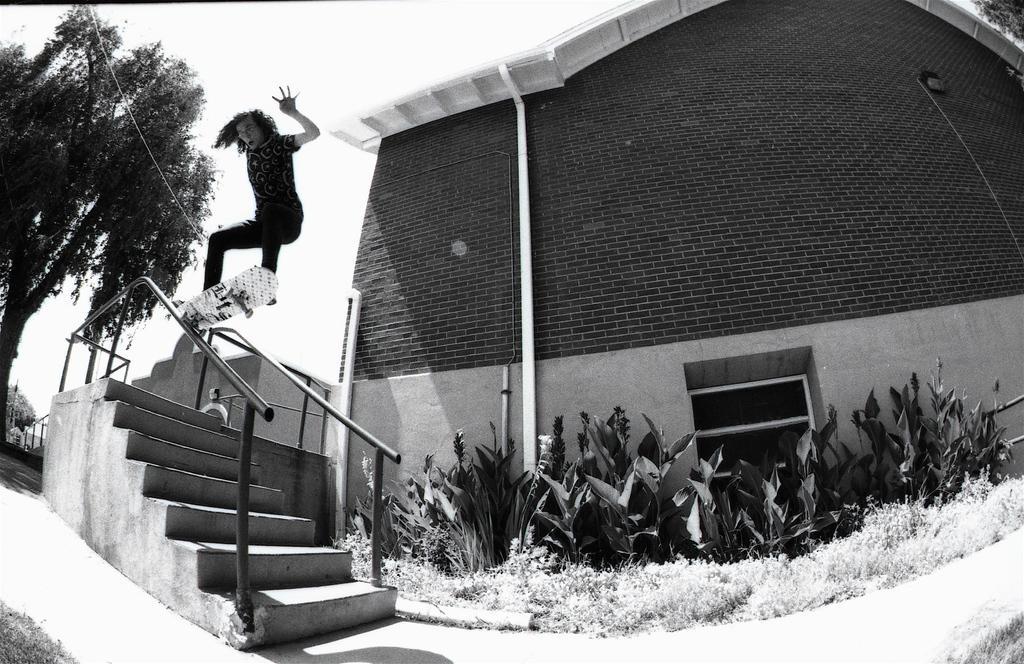In one or two sentences, can you explain what this image depicts? In the picture I can see a building, staircase, trees, plants and some other objects on the ground. Here I can see a person is doing skating on the metal rod. In the background I can see the sky. This picture is black and white in color. 